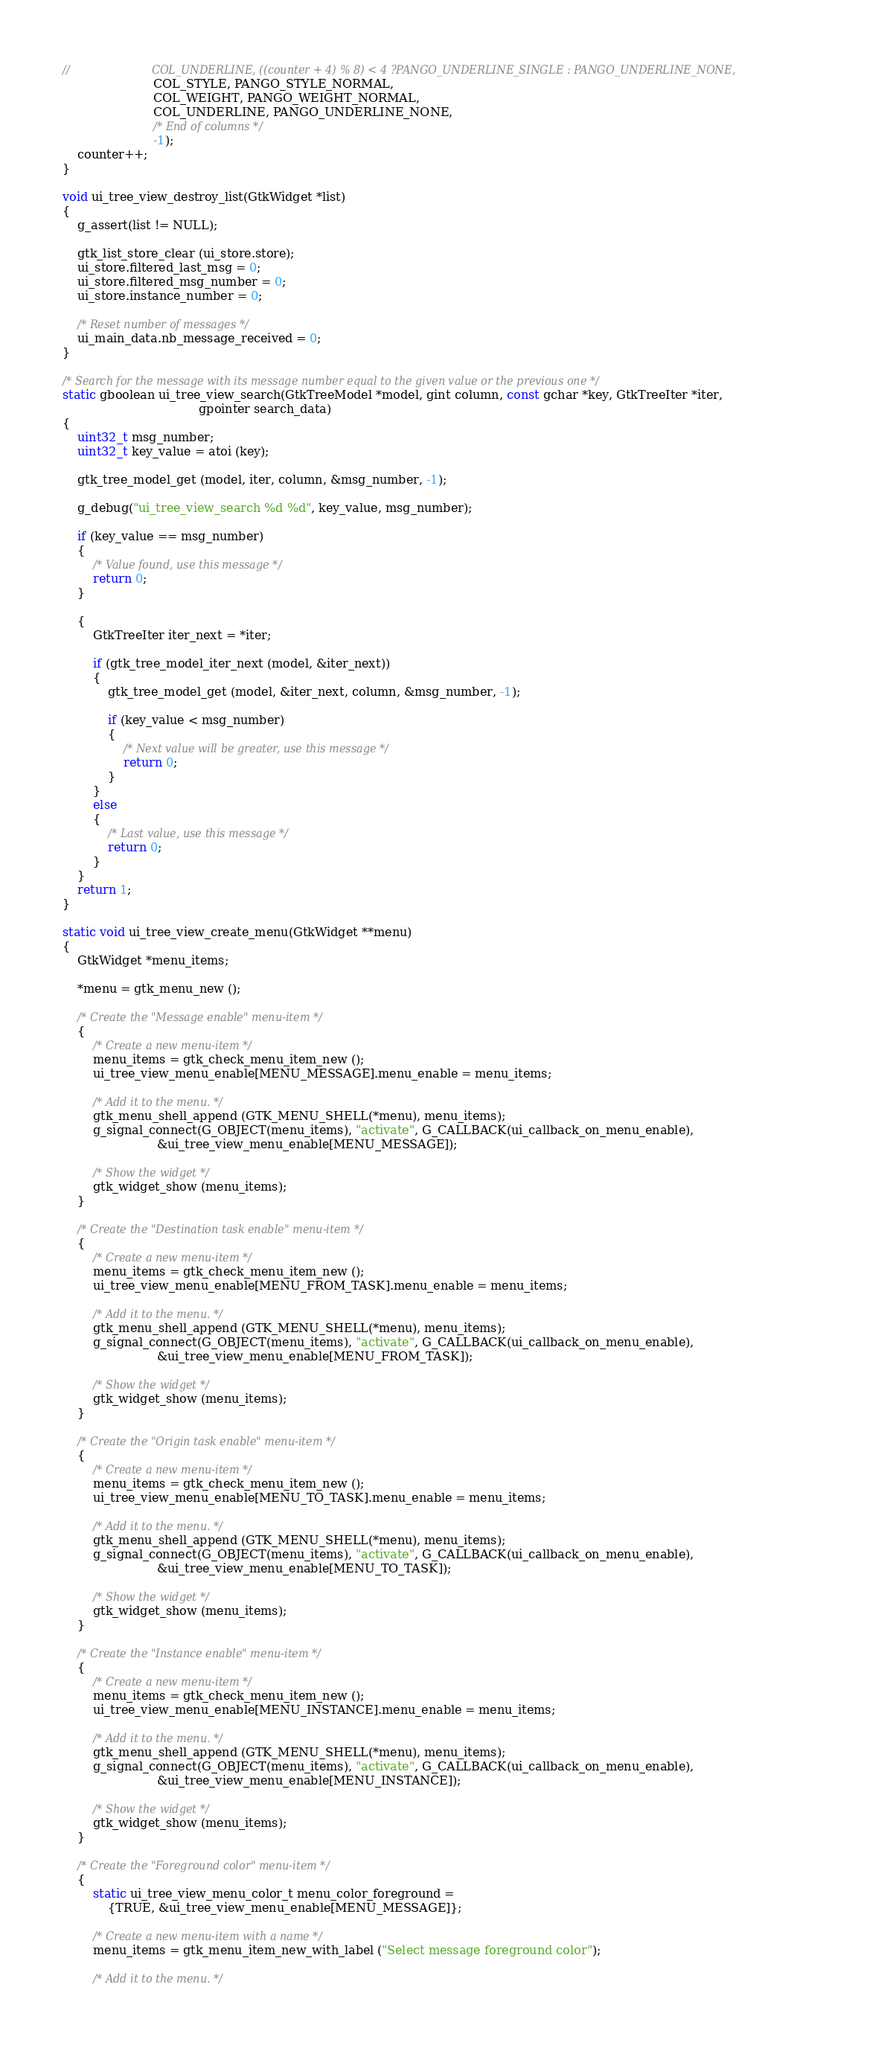<code> <loc_0><loc_0><loc_500><loc_500><_C_>//                        COL_UNDERLINE, ((counter + 4) % 8) < 4 ?PANGO_UNDERLINE_SINGLE : PANGO_UNDERLINE_NONE,
                        COL_STYLE, PANGO_STYLE_NORMAL,
                        COL_WEIGHT, PANGO_WEIGHT_NORMAL,
                        COL_UNDERLINE, PANGO_UNDERLINE_NONE,
                        /* End of columns */
                        -1);
    counter++;
}

void ui_tree_view_destroy_list(GtkWidget *list)
{
    g_assert(list != NULL);

    gtk_list_store_clear (ui_store.store);
    ui_store.filtered_last_msg = 0;
    ui_store.filtered_msg_number = 0;
    ui_store.instance_number = 0;

    /* Reset number of messages */
    ui_main_data.nb_message_received = 0;
}

/* Search for the message with its message number equal to the given value or the previous one */
static gboolean ui_tree_view_search(GtkTreeModel *model, gint column, const gchar *key, GtkTreeIter *iter,
                                    gpointer search_data)
{
    uint32_t msg_number;
    uint32_t key_value = atoi (key);

    gtk_tree_model_get (model, iter, column, &msg_number, -1);

    g_debug("ui_tree_view_search %d %d", key_value, msg_number);

    if (key_value == msg_number)
    {
        /* Value found, use this message */
        return 0;
    }

    {
        GtkTreeIter iter_next = *iter;

        if (gtk_tree_model_iter_next (model, &iter_next))
        {
            gtk_tree_model_get (model, &iter_next, column, &msg_number, -1);

            if (key_value < msg_number)
            {
                /* Next value will be greater, use this message */
                return 0;
            }
        }
        else
        {
            /* Last value, use this message */
            return 0;
        }
    }
    return 1;
}

static void ui_tree_view_create_menu(GtkWidget **menu)
{
    GtkWidget *menu_items;

    *menu = gtk_menu_new ();

    /* Create the "Message enable" menu-item */
    {
        /* Create a new menu-item */
        menu_items = gtk_check_menu_item_new ();
        ui_tree_view_menu_enable[MENU_MESSAGE].menu_enable = menu_items;

        /* Add it to the menu. */
        gtk_menu_shell_append (GTK_MENU_SHELL(*menu), menu_items);
        g_signal_connect(G_OBJECT(menu_items), "activate", G_CALLBACK(ui_callback_on_menu_enable),
                         &ui_tree_view_menu_enable[MENU_MESSAGE]);

        /* Show the widget */
        gtk_widget_show (menu_items);
    }

    /* Create the "Destination task enable" menu-item */
    {
        /* Create a new menu-item */
        menu_items = gtk_check_menu_item_new ();
        ui_tree_view_menu_enable[MENU_FROM_TASK].menu_enable = menu_items;

        /* Add it to the menu. */
        gtk_menu_shell_append (GTK_MENU_SHELL(*menu), menu_items);
        g_signal_connect(G_OBJECT(menu_items), "activate", G_CALLBACK(ui_callback_on_menu_enable),
                         &ui_tree_view_menu_enable[MENU_FROM_TASK]);

        /* Show the widget */
        gtk_widget_show (menu_items);
    }

    /* Create the "Origin task enable" menu-item */
    {
        /* Create a new menu-item */
        menu_items = gtk_check_menu_item_new ();
        ui_tree_view_menu_enable[MENU_TO_TASK].menu_enable = menu_items;

        /* Add it to the menu. */
        gtk_menu_shell_append (GTK_MENU_SHELL(*menu), menu_items);
        g_signal_connect(G_OBJECT(menu_items), "activate", G_CALLBACK(ui_callback_on_menu_enable),
                         &ui_tree_view_menu_enable[MENU_TO_TASK]);

        /* Show the widget */
        gtk_widget_show (menu_items);
    }

    /* Create the "Instance enable" menu-item */
    {
        /* Create a new menu-item */
        menu_items = gtk_check_menu_item_new ();
        ui_tree_view_menu_enable[MENU_INSTANCE].menu_enable = menu_items;

        /* Add it to the menu. */
        gtk_menu_shell_append (GTK_MENU_SHELL(*menu), menu_items);
        g_signal_connect(G_OBJECT(menu_items), "activate", G_CALLBACK(ui_callback_on_menu_enable),
                         &ui_tree_view_menu_enable[MENU_INSTANCE]);

        /* Show the widget */
        gtk_widget_show (menu_items);
    }

    /* Create the "Foreground color" menu-item */
    {
        static ui_tree_view_menu_color_t menu_color_foreground =
            {TRUE, &ui_tree_view_menu_enable[MENU_MESSAGE]};

        /* Create a new menu-item with a name */
        menu_items = gtk_menu_item_new_with_label ("Select message foreground color");

        /* Add it to the menu. */</code> 